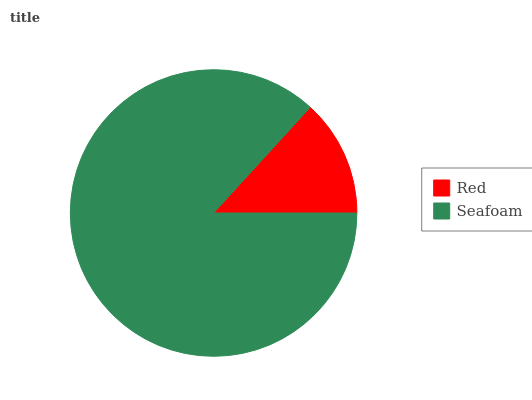Is Red the minimum?
Answer yes or no. Yes. Is Seafoam the maximum?
Answer yes or no. Yes. Is Seafoam the minimum?
Answer yes or no. No. Is Seafoam greater than Red?
Answer yes or no. Yes. Is Red less than Seafoam?
Answer yes or no. Yes. Is Red greater than Seafoam?
Answer yes or no. No. Is Seafoam less than Red?
Answer yes or no. No. Is Seafoam the high median?
Answer yes or no. Yes. Is Red the low median?
Answer yes or no. Yes. Is Red the high median?
Answer yes or no. No. Is Seafoam the low median?
Answer yes or no. No. 